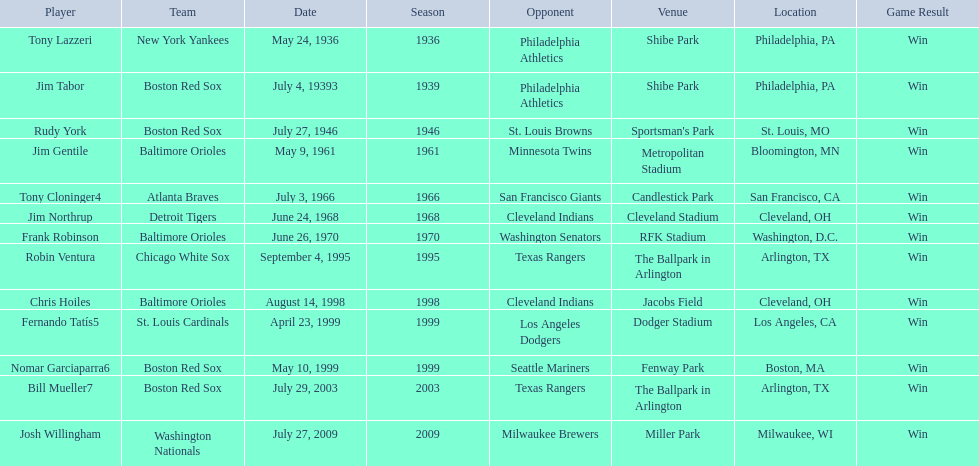What are the dates? May 24, 1936, July 4, 19393, July 27, 1946, May 9, 1961, July 3, 1966, June 24, 1968, June 26, 1970, September 4, 1995, August 14, 1998, April 23, 1999, May 10, 1999, July 29, 2003, July 27, 2009. Which date is in 1936? May 24, 1936. What player is listed for this date? Tony Lazzeri. 